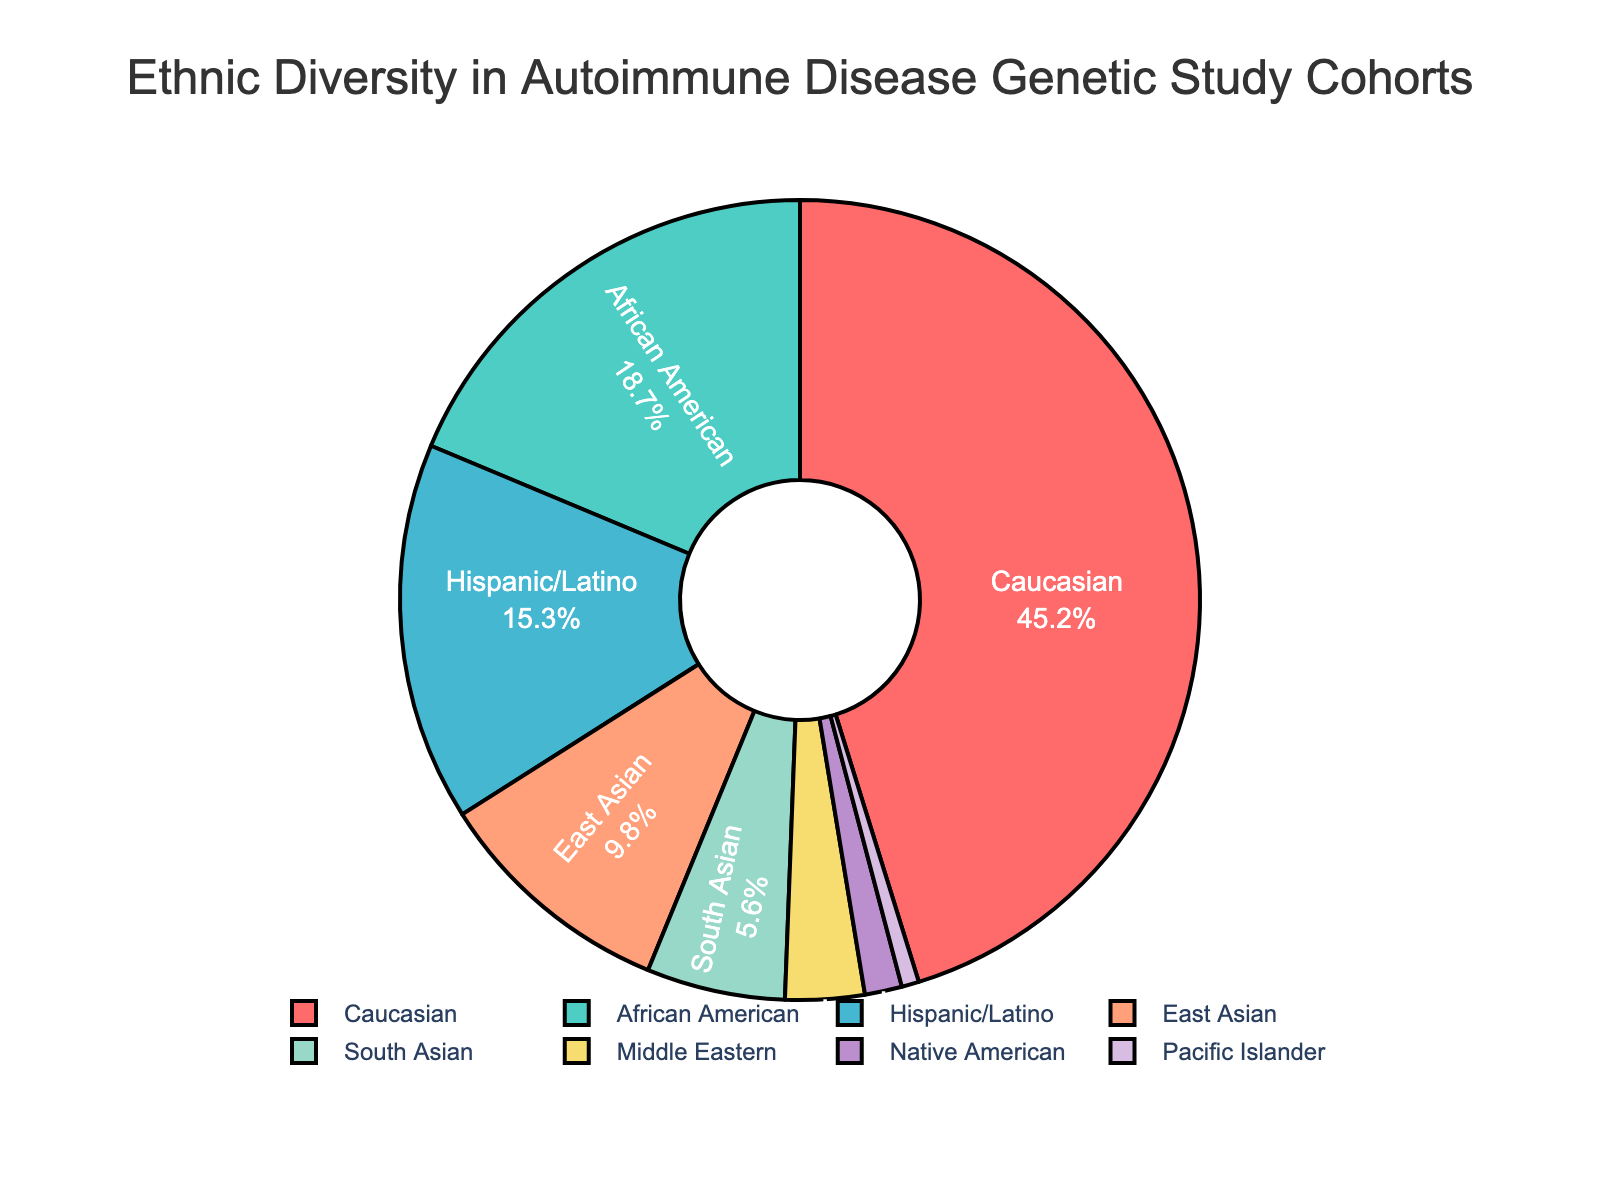Which ethnicity has the highest representation in the study cohorts? By looking at the pie chart, the largest section corresponds to the "Caucasian" group, indicating the highest representation.
Answer: Caucasian What is the combined percentage of Hispanic/Latino and African American groups? The percentage of Hispanic/Latino is 15.3%, and that of African American is 18.7%. The combined percentage is calculated as 15.3 + 18.7 = 34%.
Answer: 34% Which two ethnicities have the smallest representation and what are their combined percentages? The smallest sections of the pie chart are for the "Pacific Islander" and "Native American" groups. Their respective percentages are 0.7% and 1.5%. Their combined percentage is 0.7 + 1.5 = 2.2%.
Answer: 2.2% Is the representation of South Asian group greater than that of East Asian group? The percentage for South Asian is 5.6%, while for East Asian it is 9.8%. Since 5.6% is less than 9.8%, South Asian has a smaller representation compared to East Asian.
Answer: No What is the difference in percentage between the African American and Middle Eastern groups? The percentage representation of African American is 18.7%, and Middle Eastern is 3.2%. The difference is calculated as 18.7 - 3.2 = 15.5%.
Answer: 15.5% Which slice of the pie chart is highlighted in a red color? By observing the colors in the pie chart, the slice colored red represents the "Caucasian" ethnicity.
Answer: Caucasian What percentage of the total is made up by East Asian, South Asian, and Middle Eastern groups combined? The percentages are East Asian: 9.8%, South Asian: 5.6%, and Middle Eastern: 3.2%. Adding them gives 9.8 + 5.6 + 3.2 = 18.6%.
Answer: 18.6% How does the percentage of Hispanic/Latino compare to that of Caucasian? The Hispanic/Latino group has 15.3%, while the Caucasian group has 45.2%. The Caucasian percentage is higher.
Answer: Caucasian is higher What is the median percentage value of all the ethnic groups listed? To find the median, list the percentages in ascending order: 0.7, 1.5, 3.2, 5.6, 9.8, 15.3, 18.7, 45.2. There are 8 values, so the median is the average of the 4th and 5th values: (5.6 + 9.8) / 2 = 7.7%.
Answer: 7.7% What fraction of the total is made up by non-Caucasian groups? The percentage for Caucasian is 45.2%, so the remaining percentage (non-Caucasian groups) is 100 - 45.2 = 54.8%, which is 54.8/100 = 0.548 as a fraction.
Answer: 0.548 